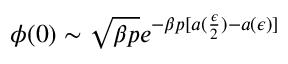<formula> <loc_0><loc_0><loc_500><loc_500>\phi ( 0 ) \sim \sqrt { \beta p } e ^ { - \beta p [ a ( \frac { \epsilon } { 2 } ) - a ( \epsilon ) ] }</formula> 